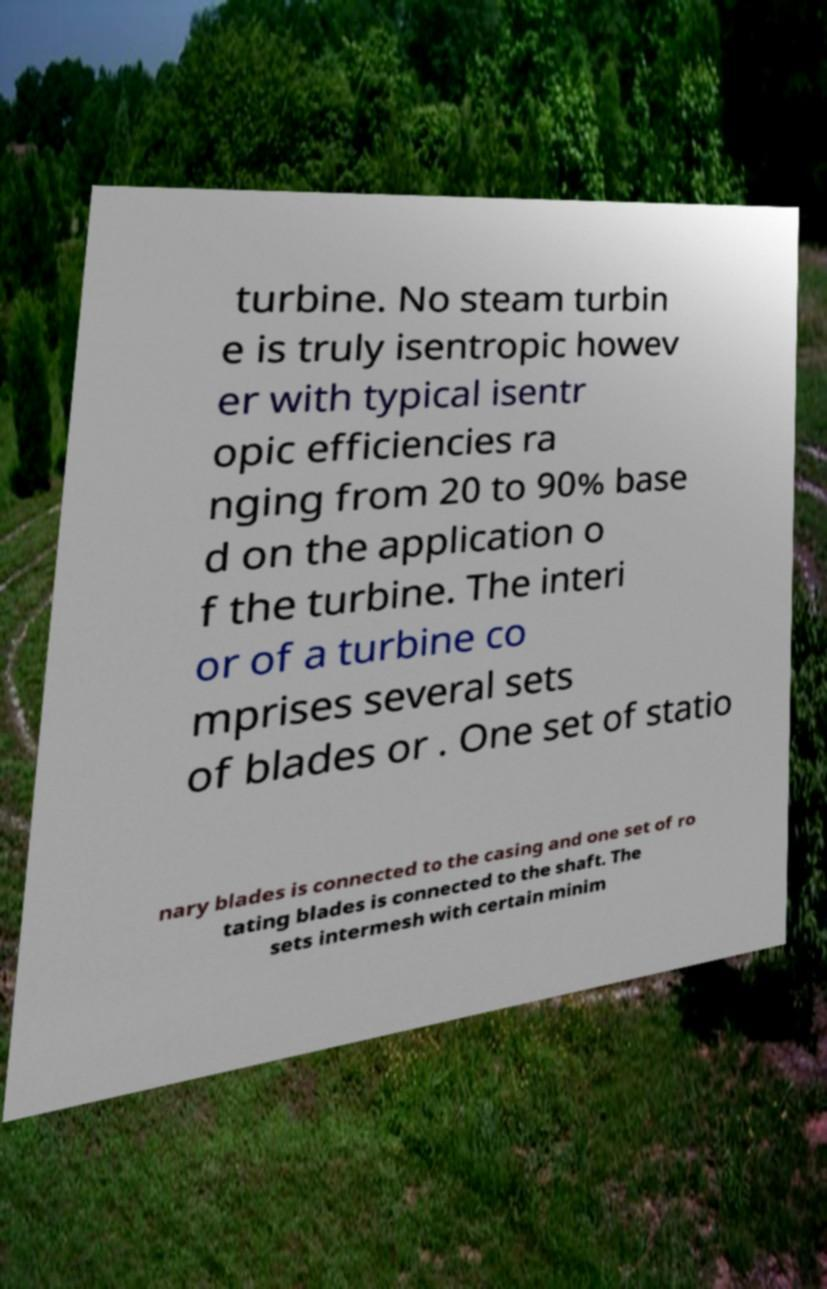Please identify and transcribe the text found in this image. turbine. No steam turbin e is truly isentropic howev er with typical isentr opic efficiencies ra nging from 20 to 90% base d on the application o f the turbine. The interi or of a turbine co mprises several sets of blades or . One set of statio nary blades is connected to the casing and one set of ro tating blades is connected to the shaft. The sets intermesh with certain minim 